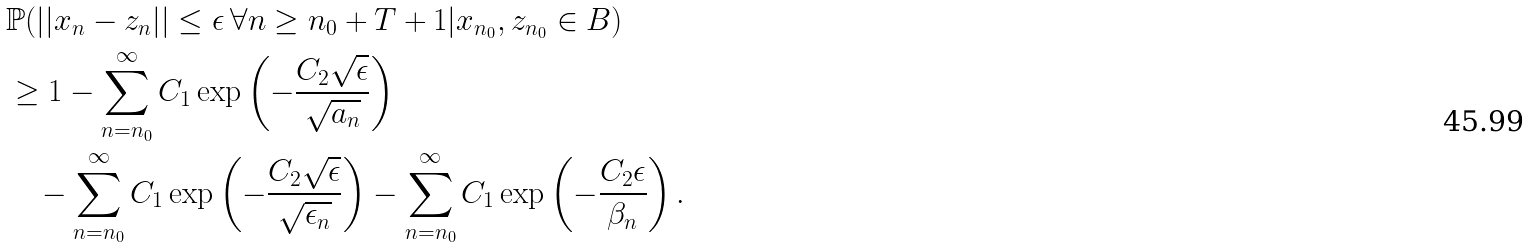<formula> <loc_0><loc_0><loc_500><loc_500>& \mathbb { P } ( | | x _ { n } - z _ { n } | | \leq \epsilon \, \forall n \geq n _ { 0 } + T + 1 | x _ { n _ { 0 } } , z _ { n _ { 0 } } \in B ) \\ & \geq 1 - \sum _ { n = n _ { 0 } } ^ { \infty } C _ { 1 } \exp \left ( - \frac { C _ { 2 } \sqrt { \epsilon } } { \sqrt { a _ { n } } } \right ) \\ & \quad - \sum _ { n = n _ { 0 } } ^ { \infty } C _ { 1 } \exp \left ( - \frac { C _ { 2 } \sqrt { \epsilon } } { \sqrt { \epsilon _ { n } } } \right ) - \sum _ { n = n _ { 0 } } ^ { \infty } C _ { 1 } \exp \left ( - \frac { C _ { 2 } \epsilon } { \beta _ { n } } \right ) .</formula> 